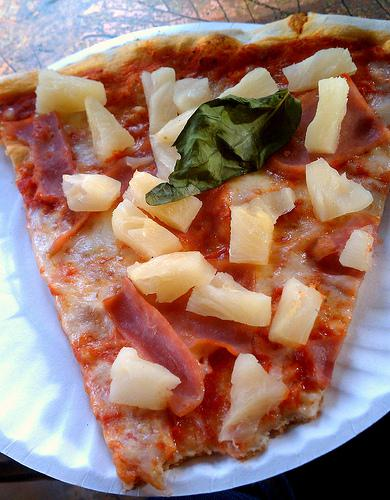Question: what is on the plate?
Choices:
A. Salad.
B. Macaroni.
C. Hamburger.
D. A slice of pizza.
Answer with the letter. Answer: D Question: what kind of pizza is this?
Choices:
A. Vegetarian.
B. Pepperoni and pineapple.
C. Sausage.
D. Deep dish.
Answer with the letter. Answer: B 